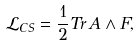<formula> <loc_0><loc_0><loc_500><loc_500>\mathcal { L } _ { C S } = \frac { 1 } { 2 } T r \, { A } \wedge F ,</formula> 